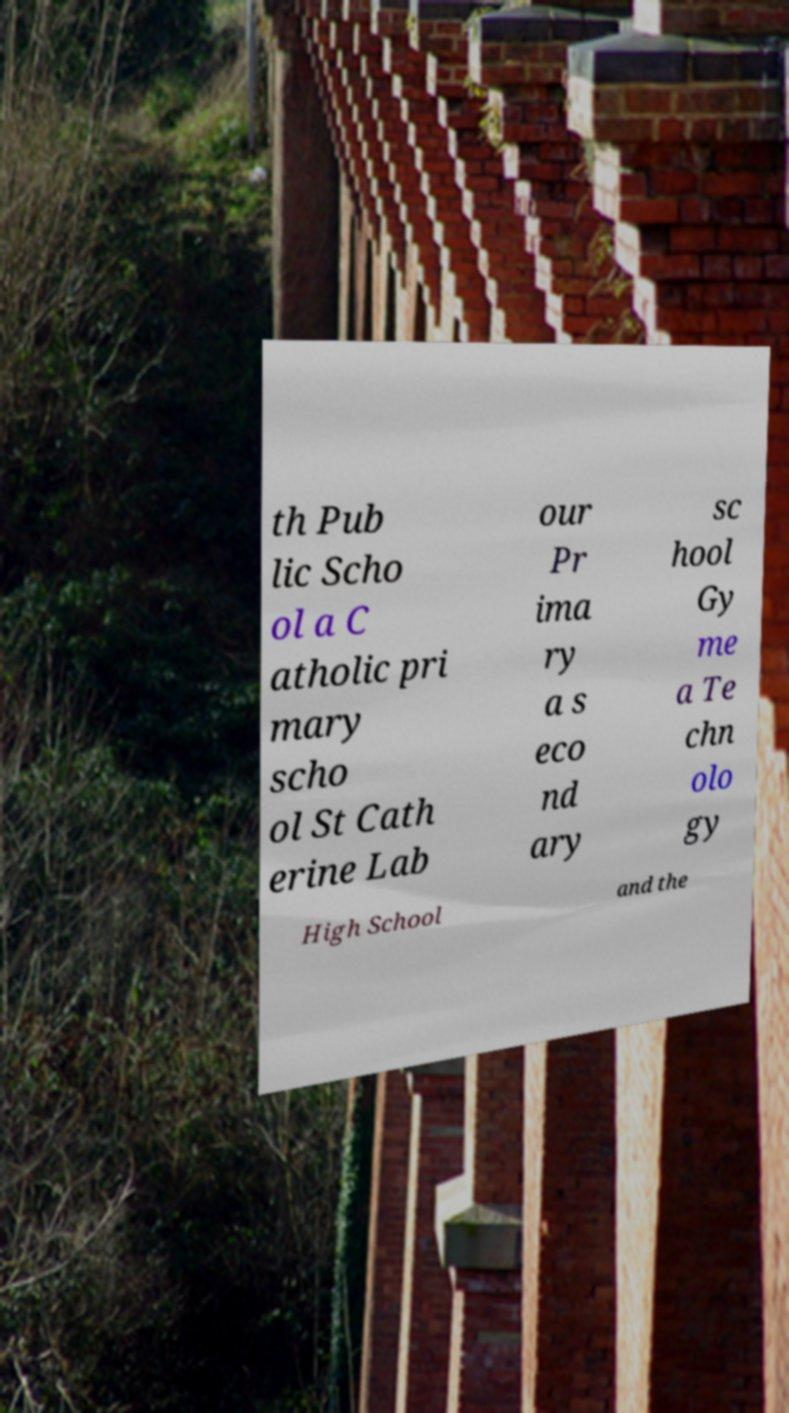Please identify and transcribe the text found in this image. th Pub lic Scho ol a C atholic pri mary scho ol St Cath erine Lab our Pr ima ry a s eco nd ary sc hool Gy me a Te chn olo gy High School and the 